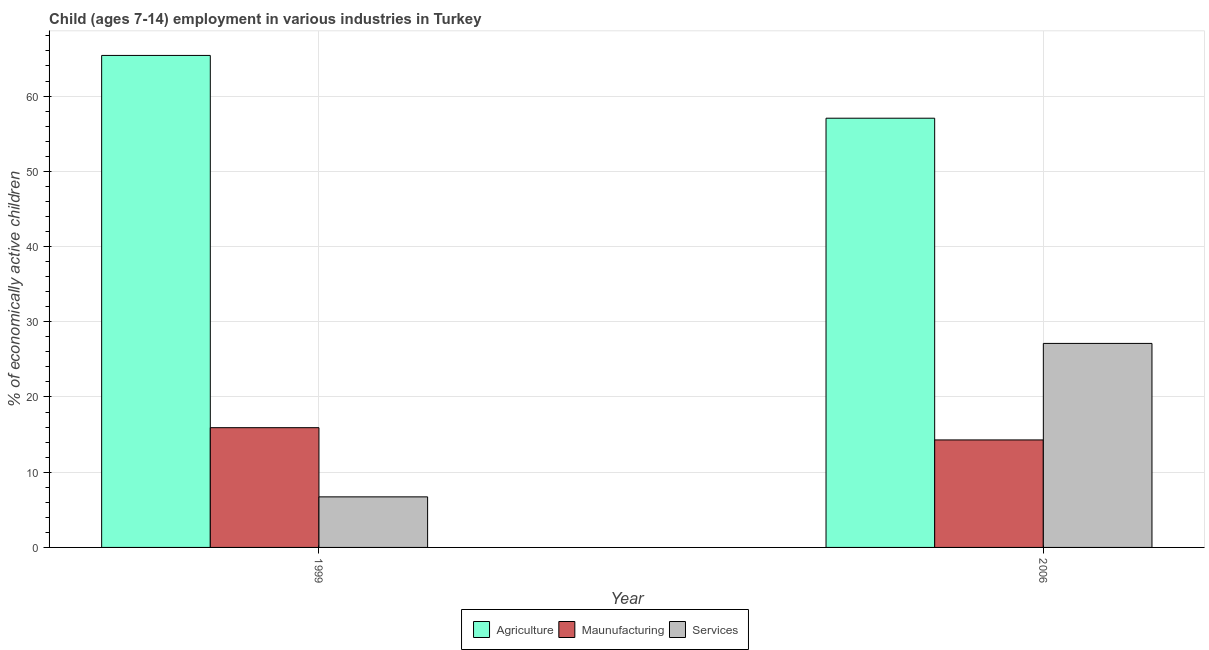How many different coloured bars are there?
Your response must be concise. 3. How many groups of bars are there?
Make the answer very short. 2. Are the number of bars on each tick of the X-axis equal?
Offer a very short reply. Yes. How many bars are there on the 1st tick from the left?
Keep it short and to the point. 3. What is the label of the 2nd group of bars from the left?
Provide a short and direct response. 2006. In how many cases, is the number of bars for a given year not equal to the number of legend labels?
Make the answer very short. 0. What is the percentage of economically active children in manufacturing in 2006?
Your answer should be very brief. 14.29. Across all years, what is the maximum percentage of economically active children in manufacturing?
Make the answer very short. 15.92. Across all years, what is the minimum percentage of economically active children in services?
Give a very brief answer. 6.72. In which year was the percentage of economically active children in agriculture minimum?
Your response must be concise. 2006. What is the total percentage of economically active children in services in the graph?
Offer a very short reply. 33.84. What is the difference between the percentage of economically active children in manufacturing in 1999 and that in 2006?
Ensure brevity in your answer.  1.63. What is the difference between the percentage of economically active children in services in 1999 and the percentage of economically active children in agriculture in 2006?
Your answer should be very brief. -20.4. What is the average percentage of economically active children in agriculture per year?
Provide a succinct answer. 61.23. In how many years, is the percentage of economically active children in services greater than 2 %?
Your response must be concise. 2. What is the ratio of the percentage of economically active children in agriculture in 1999 to that in 2006?
Ensure brevity in your answer.  1.15. Is the percentage of economically active children in agriculture in 1999 less than that in 2006?
Your answer should be compact. No. In how many years, is the percentage of economically active children in agriculture greater than the average percentage of economically active children in agriculture taken over all years?
Provide a short and direct response. 1. What does the 2nd bar from the left in 1999 represents?
Make the answer very short. Maunufacturing. What does the 2nd bar from the right in 2006 represents?
Offer a terse response. Maunufacturing. Is it the case that in every year, the sum of the percentage of economically active children in agriculture and percentage of economically active children in manufacturing is greater than the percentage of economically active children in services?
Make the answer very short. Yes. Does the graph contain any zero values?
Keep it short and to the point. No. Does the graph contain grids?
Offer a very short reply. Yes. Where does the legend appear in the graph?
Ensure brevity in your answer.  Bottom center. How are the legend labels stacked?
Your answer should be compact. Horizontal. What is the title of the graph?
Your response must be concise. Child (ages 7-14) employment in various industries in Turkey. Does "Private sector" appear as one of the legend labels in the graph?
Offer a terse response. No. What is the label or title of the X-axis?
Offer a very short reply. Year. What is the label or title of the Y-axis?
Provide a short and direct response. % of economically active children. What is the % of economically active children of Agriculture in 1999?
Provide a short and direct response. 65.41. What is the % of economically active children in Maunufacturing in 1999?
Your answer should be compact. 15.92. What is the % of economically active children in Services in 1999?
Ensure brevity in your answer.  6.72. What is the % of economically active children of Agriculture in 2006?
Give a very brief answer. 57.06. What is the % of economically active children in Maunufacturing in 2006?
Make the answer very short. 14.29. What is the % of economically active children in Services in 2006?
Your response must be concise. 27.12. Across all years, what is the maximum % of economically active children of Agriculture?
Give a very brief answer. 65.41. Across all years, what is the maximum % of economically active children in Maunufacturing?
Offer a terse response. 15.92. Across all years, what is the maximum % of economically active children in Services?
Your response must be concise. 27.12. Across all years, what is the minimum % of economically active children of Agriculture?
Ensure brevity in your answer.  57.06. Across all years, what is the minimum % of economically active children of Maunufacturing?
Offer a very short reply. 14.29. Across all years, what is the minimum % of economically active children in Services?
Make the answer very short. 6.72. What is the total % of economically active children of Agriculture in the graph?
Your answer should be compact. 122.47. What is the total % of economically active children of Maunufacturing in the graph?
Make the answer very short. 30.21. What is the total % of economically active children in Services in the graph?
Provide a succinct answer. 33.84. What is the difference between the % of economically active children in Agriculture in 1999 and that in 2006?
Offer a very short reply. 8.35. What is the difference between the % of economically active children of Maunufacturing in 1999 and that in 2006?
Provide a short and direct response. 1.63. What is the difference between the % of economically active children of Services in 1999 and that in 2006?
Offer a terse response. -20.4. What is the difference between the % of economically active children of Agriculture in 1999 and the % of economically active children of Maunufacturing in 2006?
Your answer should be very brief. 51.12. What is the difference between the % of economically active children in Agriculture in 1999 and the % of economically active children in Services in 2006?
Your answer should be compact. 38.29. What is the difference between the % of economically active children of Maunufacturing in 1999 and the % of economically active children of Services in 2006?
Keep it short and to the point. -11.2. What is the average % of economically active children of Agriculture per year?
Keep it short and to the point. 61.23. What is the average % of economically active children of Maunufacturing per year?
Give a very brief answer. 15.1. What is the average % of economically active children in Services per year?
Your answer should be compact. 16.92. In the year 1999, what is the difference between the % of economically active children in Agriculture and % of economically active children in Maunufacturing?
Provide a short and direct response. 49.49. In the year 1999, what is the difference between the % of economically active children of Agriculture and % of economically active children of Services?
Provide a succinct answer. 58.68. In the year 1999, what is the difference between the % of economically active children of Maunufacturing and % of economically active children of Services?
Offer a very short reply. 9.2. In the year 2006, what is the difference between the % of economically active children of Agriculture and % of economically active children of Maunufacturing?
Your answer should be very brief. 42.77. In the year 2006, what is the difference between the % of economically active children of Agriculture and % of economically active children of Services?
Your response must be concise. 29.94. In the year 2006, what is the difference between the % of economically active children of Maunufacturing and % of economically active children of Services?
Offer a very short reply. -12.83. What is the ratio of the % of economically active children in Agriculture in 1999 to that in 2006?
Your answer should be very brief. 1.15. What is the ratio of the % of economically active children of Maunufacturing in 1999 to that in 2006?
Keep it short and to the point. 1.11. What is the ratio of the % of economically active children in Services in 1999 to that in 2006?
Keep it short and to the point. 0.25. What is the difference between the highest and the second highest % of economically active children of Agriculture?
Make the answer very short. 8.35. What is the difference between the highest and the second highest % of economically active children in Maunufacturing?
Make the answer very short. 1.63. What is the difference between the highest and the second highest % of economically active children in Services?
Make the answer very short. 20.4. What is the difference between the highest and the lowest % of economically active children of Agriculture?
Provide a succinct answer. 8.35. What is the difference between the highest and the lowest % of economically active children in Maunufacturing?
Your response must be concise. 1.63. What is the difference between the highest and the lowest % of economically active children of Services?
Ensure brevity in your answer.  20.4. 